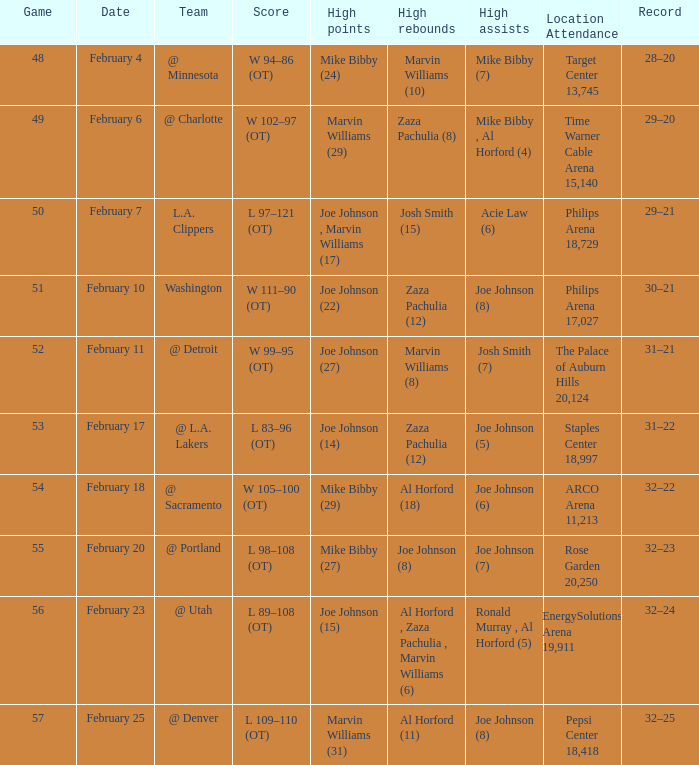What is the count of high assists stats that occurred on the 4th of february? 1.0. 